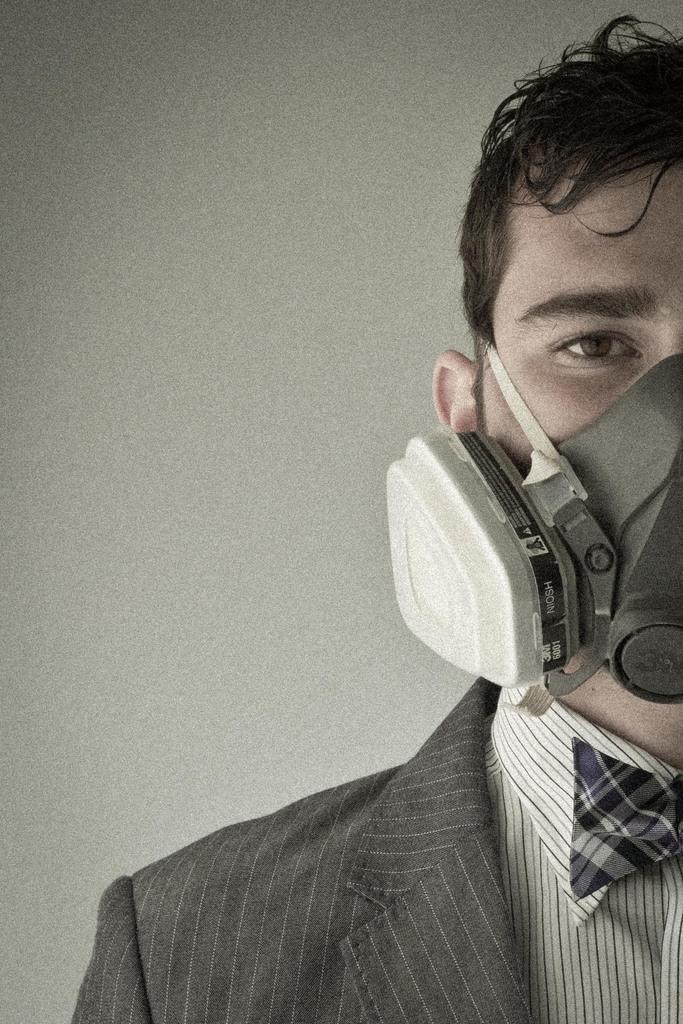Can you describe this image briefly? In this image I can see a person and there is a mask on his face. In the background it looks like a wall. 